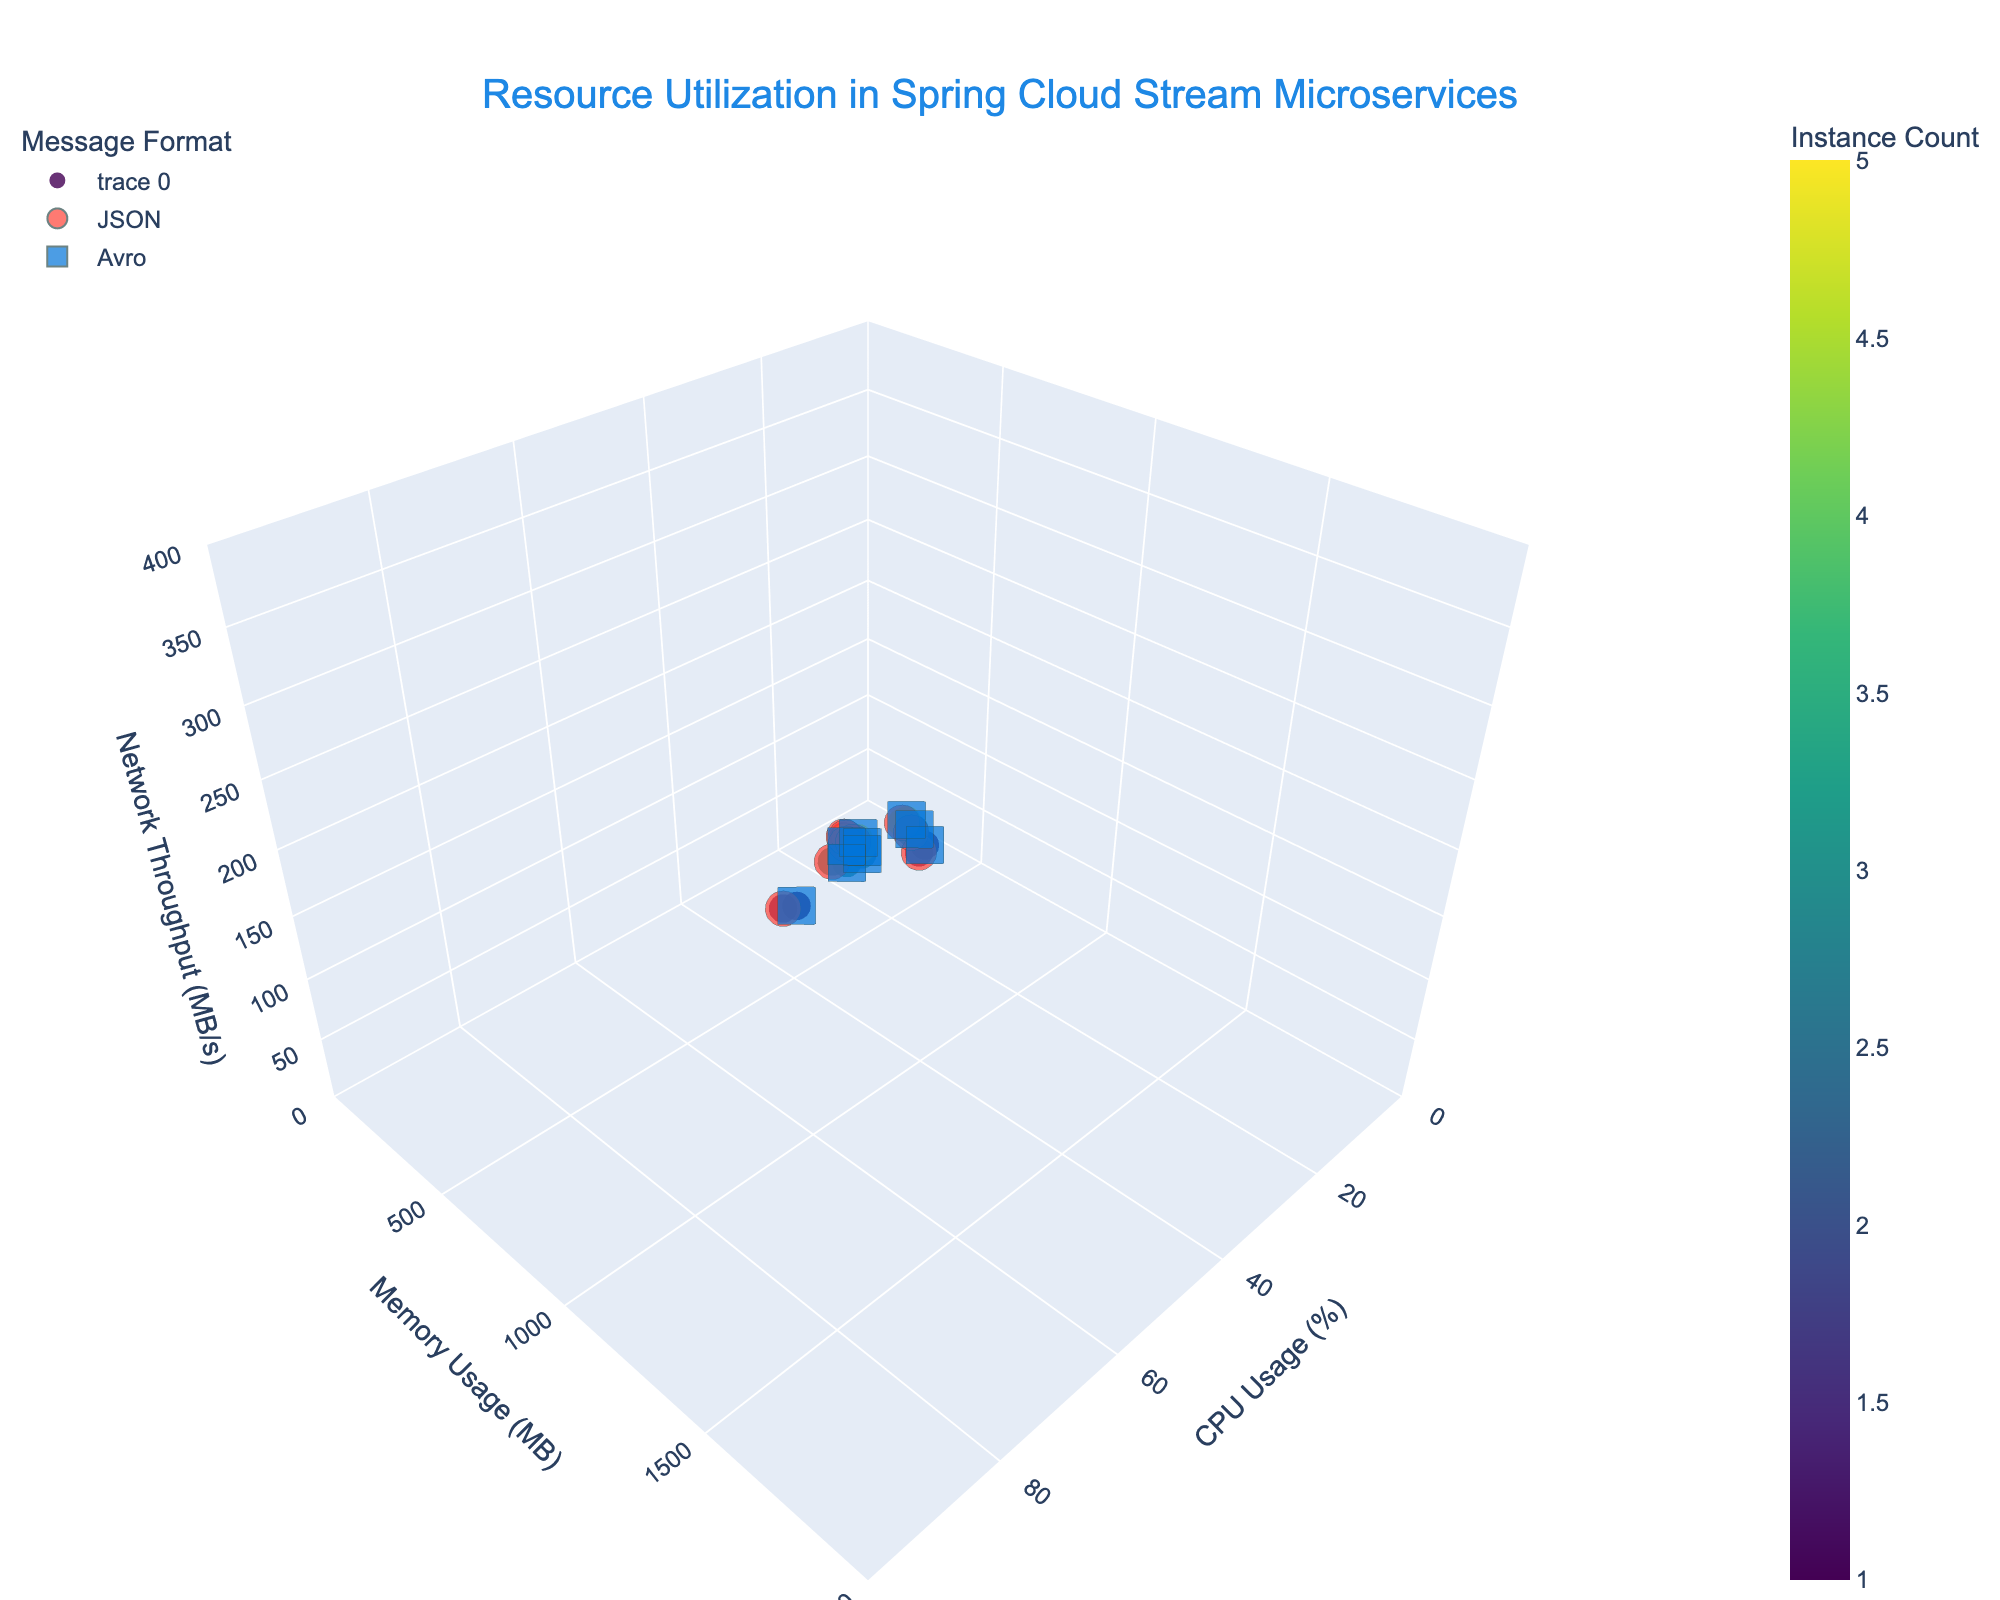What's the title of the figure? The title is located at the top center of the figure. It describes the overall subject of the data visualized.
Answer: Resource Utilization in Spring Cloud Stream Microservices What's the color scheme used for the markers, and what does it represent? The color scheme ranges from lighter to darker colors, derived from "Viridis," representing different instance counts. Lighter colors indicate fewer instances, while darker colors indicate more.
Answer: Instance Count How many unique message formats are displayed in the figure? By examining the shape indicators for message formats, we see two distinct shapes (circles and squares), corresponding to the unique message formats.
Answer: 2 Which combination of instance count and message format has the highest CPU usage under a spiky load pattern? To find this, look at the data points under the 'Spiky' load pattern with the highest CPU usage. The highest CPU usage under 'Spiky' load is at 80% for 1 instance and JSON format.
Answer: 1 instance, JSON Which message format shows lower memory usage overall based on the figure? Compare the aggregate memory usage of data points for both message formats, noting that Avro generally appears to have lower memory usage compared to JSON.
Answer: Avro For a constant high load pattern, which instance count has the lowest network throughput for Avro message format? Find the markers for high constant load under the Avro format and compare the network throughput values. The lowest network throughput is for 5 instances.
Answer: 5 instances What is the general trend in CPU usage as the number of instances increases for JSON message format under high constant load? Observe the markers for JSON format under high constant load. CPU usage decreases as the number of instances increases.
Answer: Decreasing Calculate the average memory usage for all data points with 3 instances. Sum the memory usage values for 3 instances (384+768+1152+360+720+1080=4464) and divide by the number of data points (6): 4464/6.
Answer: 744 MB Compare the network throughput between the lowest and highest instance counts for low constant load pattern in Avro format. Look at the markers for low constant load in Avro format for both 1 and 5 instances. The network throughput is 45 MB/s for 1 instance and 30 MB/s for 5 instances.
Answer: 15 MB/s What visual features distinguish between different load patterns in the figure? Different load patterns are indicated by hover text and exhibit distinct clusters in 3D space along the CPU, memory, and network axes.
Answer: Hover text and clustering 